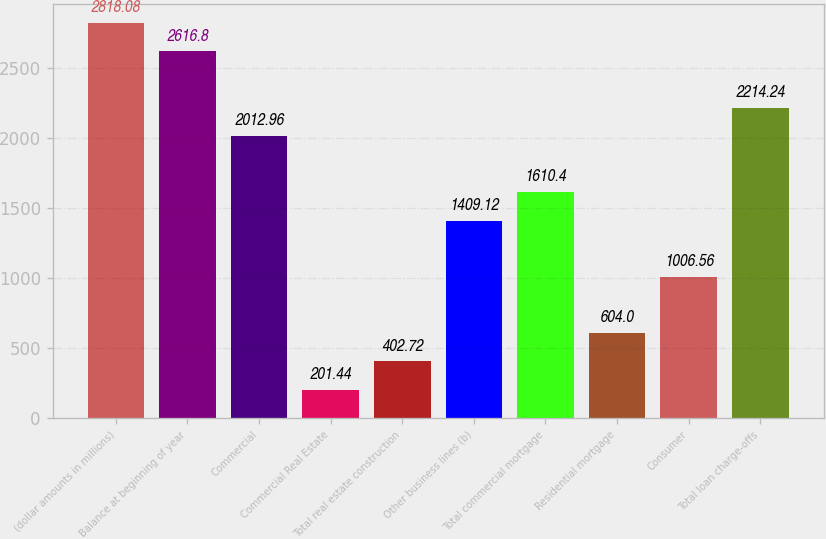Convert chart to OTSL. <chart><loc_0><loc_0><loc_500><loc_500><bar_chart><fcel>(dollar amounts in millions)<fcel>Balance at beginning of year<fcel>Commercial<fcel>Commercial Real Estate<fcel>Total real estate construction<fcel>Other business lines (b)<fcel>Total commercial mortgage<fcel>Residential mortgage<fcel>Consumer<fcel>Total loan charge-offs<nl><fcel>2818.08<fcel>2616.8<fcel>2012.96<fcel>201.44<fcel>402.72<fcel>1409.12<fcel>1610.4<fcel>604<fcel>1006.56<fcel>2214.24<nl></chart> 